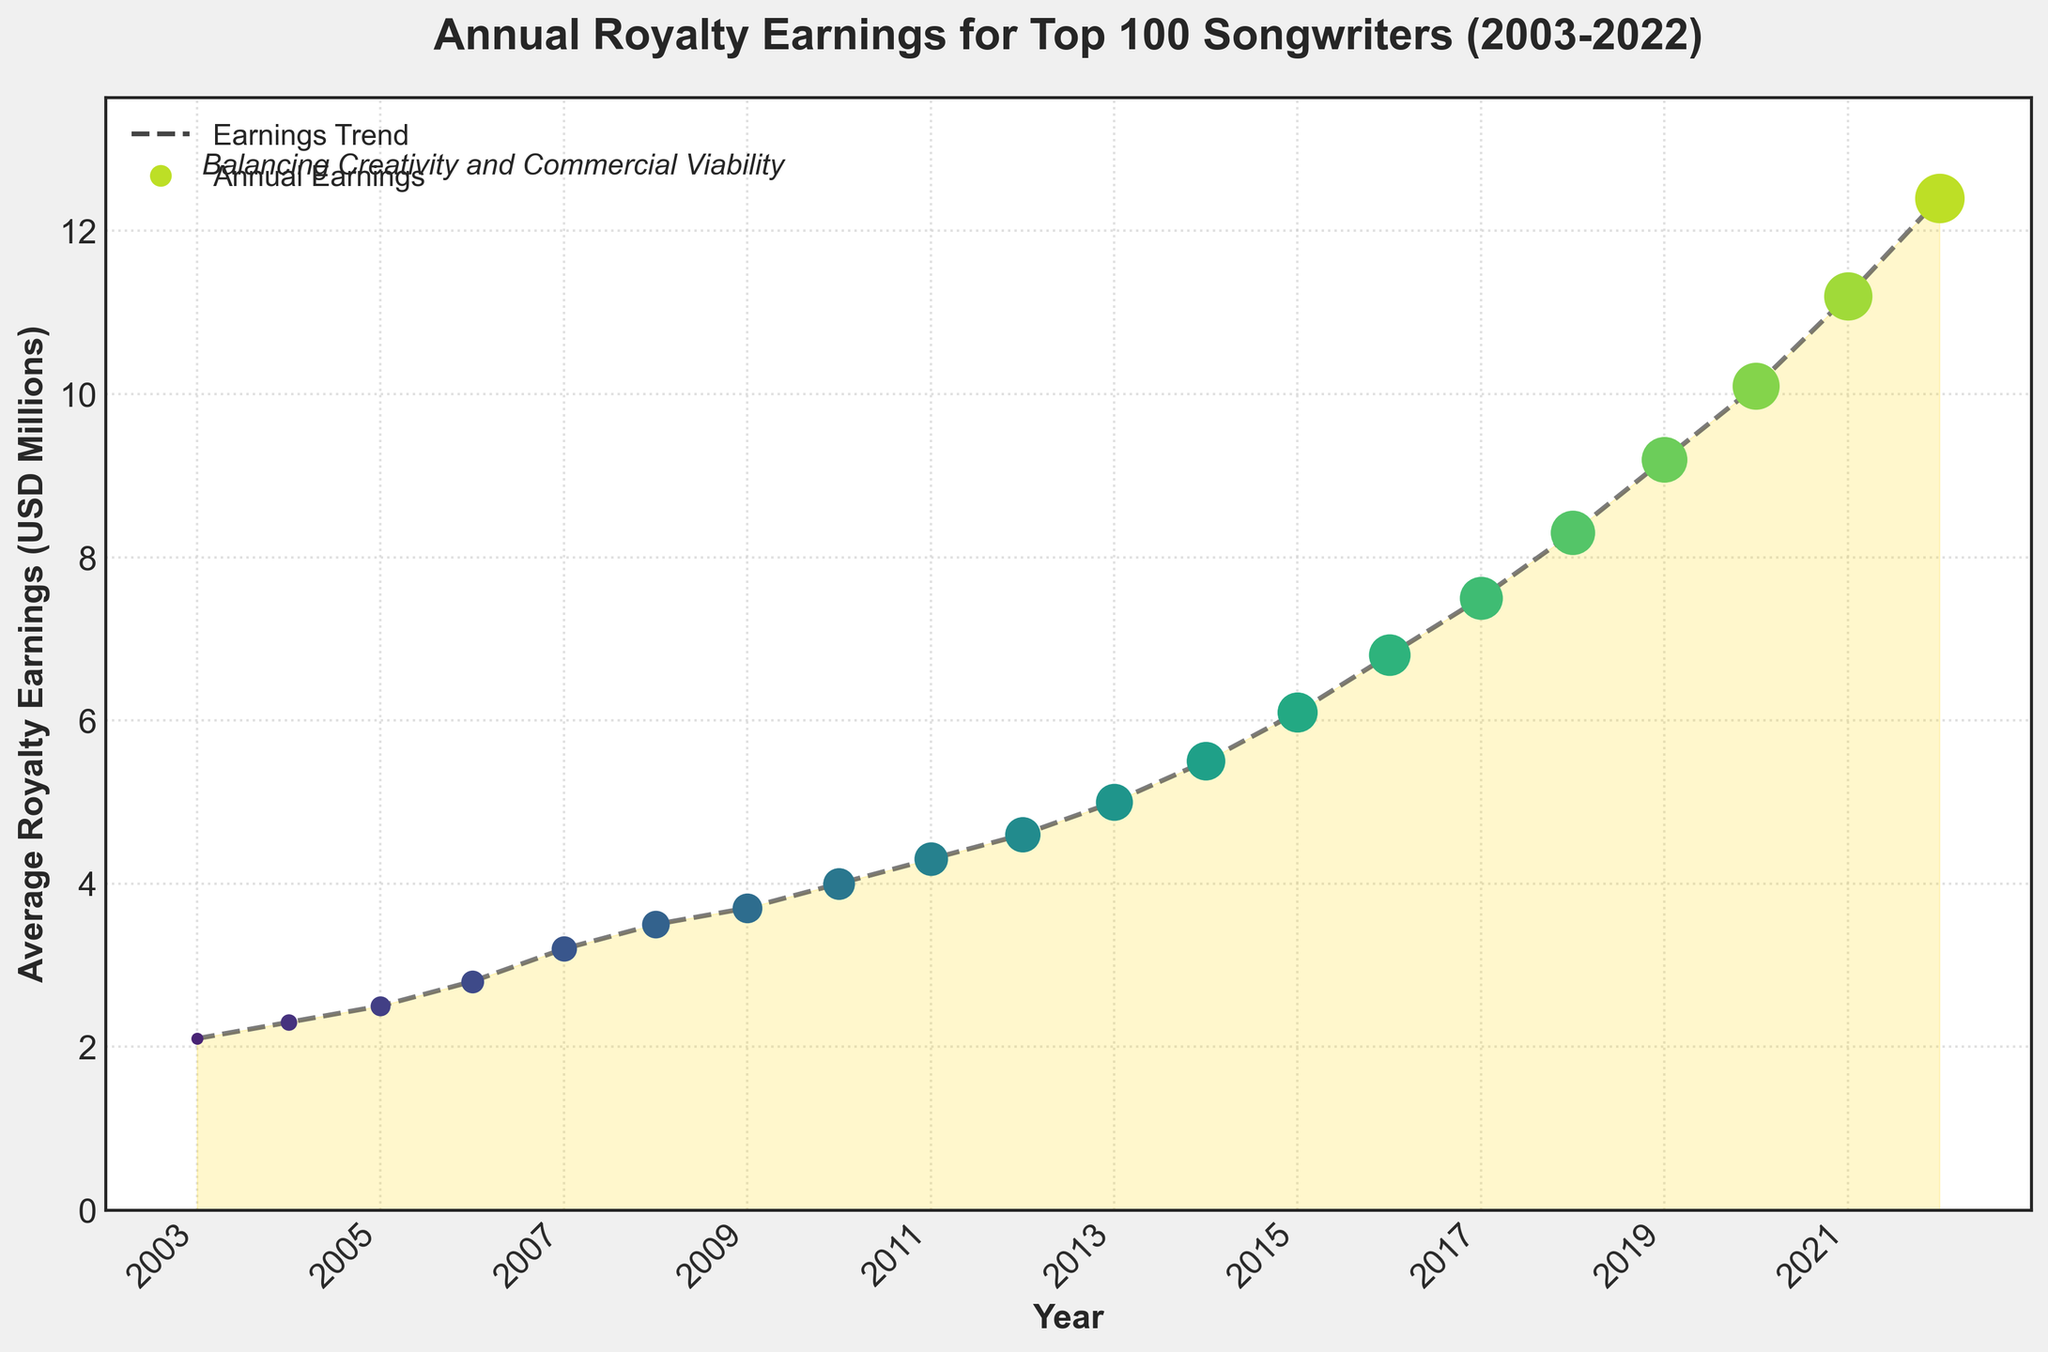What trend can you observe from the annual royalty earnings for the top 100 songwriters over the last 20 years? To determine the trend, observe the line connecting the data points from 2003 to 2022. There is a clear upward trend where royalty earnings increase each year, starting from $2.1 million in 2003 and reaching $12.4 million in 2022. This indicates a consistent growth in royalty earnings over the period.
Answer: Upward trend In which year did the annual royalty earnings exceed $5 million for the first time? To find the year when earnings first exceeded $5 million, locate the data points above $5 million on the y-axis. The first such data point is at the year 2014 with earnings of $5.5 million.
Answer: 2014 By how much did the average royalty earnings increase from 2007 to 2015? To find the increase, subtract the 2007 earnings from the 2015 earnings. The earnings in 2007 are $3.2 million, and in 2015 they are $6.1 million. Thus, the increase is $6.1 million - $3.2 million = $2.9 million.
Answer: $2.9 million Compare the royalty earnings between 2010 and 2020. By what factor did it increase? To find the factor of increase, divide the 2020 earnings by the 2010 earnings. The earnings in 2010 are $4.0 million, and in 2020 they are $10.1 million. The factor of increase is $10.1 million / $4.0 million = 2.525.
Answer: 2.525 What was the largest annual percentage increase in royalty earnings, and between which years did it occur? To find the largest annual percentage increase, calculate the year-to-year percentage changes and identify the maximum. For each year, subtract the previous year’s earnings, divide by the previous year’s earnings, and multiply by 100. The largest percentage increase is from 2019 to 2020: (($10.1 million - $9.2 million) / $9.2 million) * 100 = approx. 9.78%.
Answer: approx. 9.78% (2019-2020) What is the difference in royalty earnings between the beginning and end of the data series? To find the difference, subtract the 2003 earnings from the 2022 earnings. The earnings in 2003 are $2.1 million, and in 2022 they are $12.4 million. Therefore, the difference is $12.4 million - $2.1 million = $10.3 million.
Answer: $10.3 million What visual element indicates the overall trend of the royalty earnings? The overall trend is indicated by the line connecting the scatter points, which is dashed and shows the earnings trend. This line slopes upwards, showing increasing royalty earnings over time.
Answer: Dashed line How does the visual representation enhance understanding the trend of royalty earnings? The plot uses gradient colors to highlight the change over time, with the colors becoming more intense as the years progress. The increasing size of scatter markers emphasizes the rising earnings, and the filled area under the curve adds visual weight to the growth trend.
Answer: Gradient colors, increasing marker size, filled area Did any year experience a decrease in royalty earnings compared to the previous year? To answer this, examine the graph to see if any data point is lower than the preceding one. All data points consistently increase, indicating no year experienced a decrease in royalty earnings.
Answer: No 